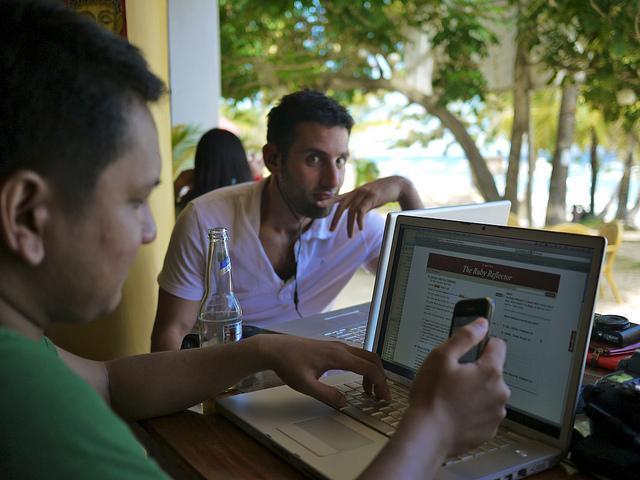How many laptops are there?
Give a very brief answer. 2. How many people are there?
Give a very brief answer. 3. 